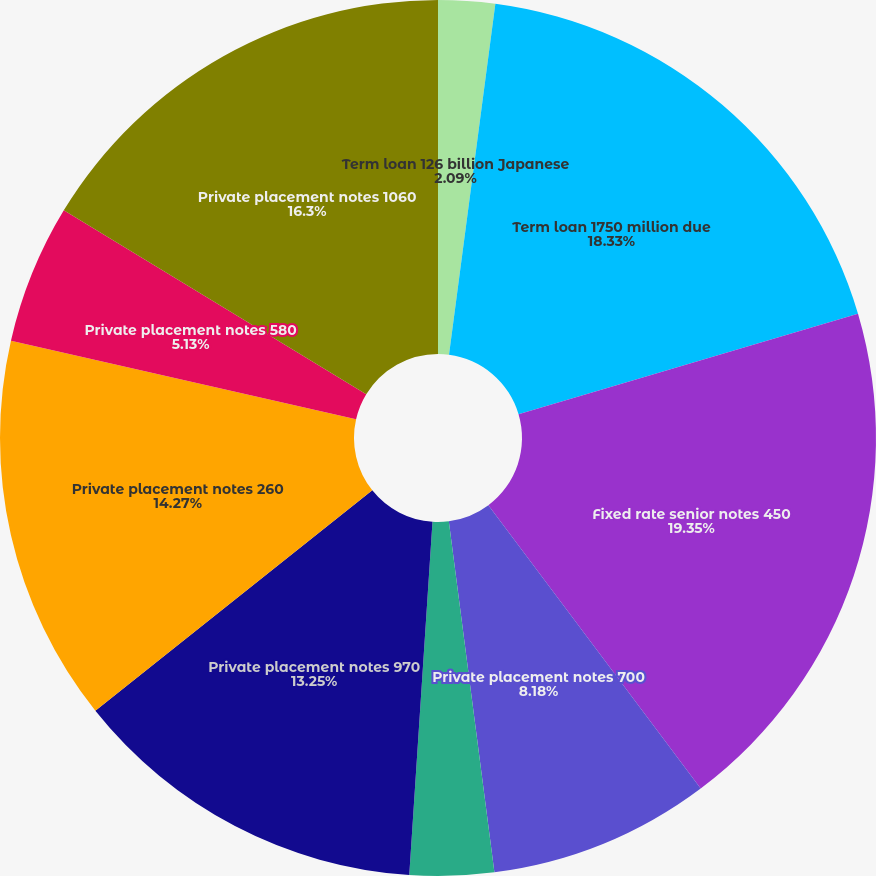<chart> <loc_0><loc_0><loc_500><loc_500><pie_chart><fcel>Term loan 126 billion Japanese<fcel>Term loan 1750 million due<fcel>Fixed rate senior notes 450<fcel>Private placement notes 700<fcel>Private placement notes 250<fcel>Private placement notes 970<fcel>Private placement notes 260<fcel>Private placement notes 580<fcel>Private placement notes 1060<nl><fcel>2.09%<fcel>18.33%<fcel>19.34%<fcel>8.18%<fcel>3.1%<fcel>13.25%<fcel>14.27%<fcel>5.13%<fcel>16.3%<nl></chart> 